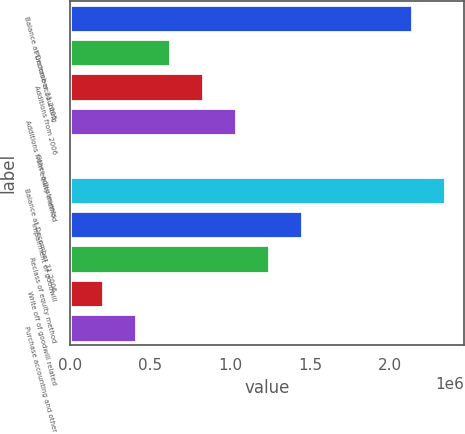Convert chart. <chart><loc_0><loc_0><loc_500><loc_500><bar_chart><fcel>Balance at December 31 2005<fcel>Purchase accounting<fcel>Additions from 2006<fcel>Additions from equity method<fcel>Other adjustments<fcel>Balance at December 31 2006<fcel>Impairment of goodwill<fcel>Reclass of equity method<fcel>Write off of goodwill related<fcel>Purchase accounting and other<nl><fcel>2.14062e+06<fcel>622178<fcel>829427<fcel>1.03668e+06<fcel>431<fcel>2.34787e+06<fcel>1.45117e+06<fcel>1.24392e+06<fcel>207680<fcel>414929<nl></chart> 